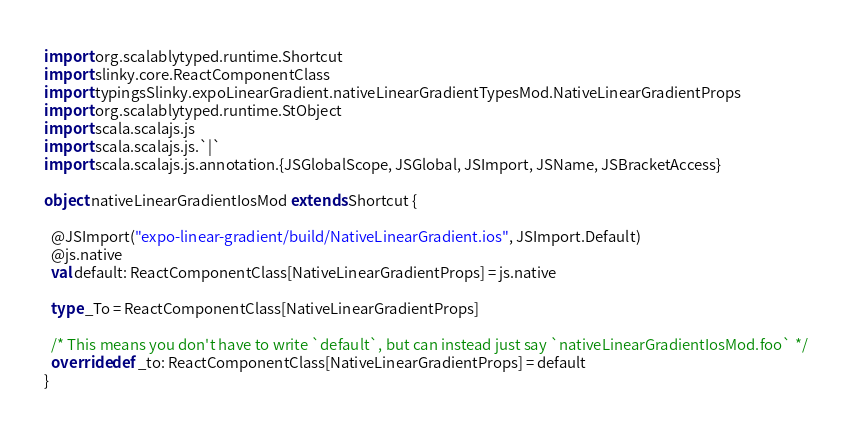<code> <loc_0><loc_0><loc_500><loc_500><_Scala_>
import org.scalablytyped.runtime.Shortcut
import slinky.core.ReactComponentClass
import typingsSlinky.expoLinearGradient.nativeLinearGradientTypesMod.NativeLinearGradientProps
import org.scalablytyped.runtime.StObject
import scala.scalajs.js
import scala.scalajs.js.`|`
import scala.scalajs.js.annotation.{JSGlobalScope, JSGlobal, JSImport, JSName, JSBracketAccess}

object nativeLinearGradientIosMod extends Shortcut {
  
  @JSImport("expo-linear-gradient/build/NativeLinearGradient.ios", JSImport.Default)
  @js.native
  val default: ReactComponentClass[NativeLinearGradientProps] = js.native
  
  type _To = ReactComponentClass[NativeLinearGradientProps]
  
  /* This means you don't have to write `default`, but can instead just say `nativeLinearGradientIosMod.foo` */
  override def _to: ReactComponentClass[NativeLinearGradientProps] = default
}
</code> 